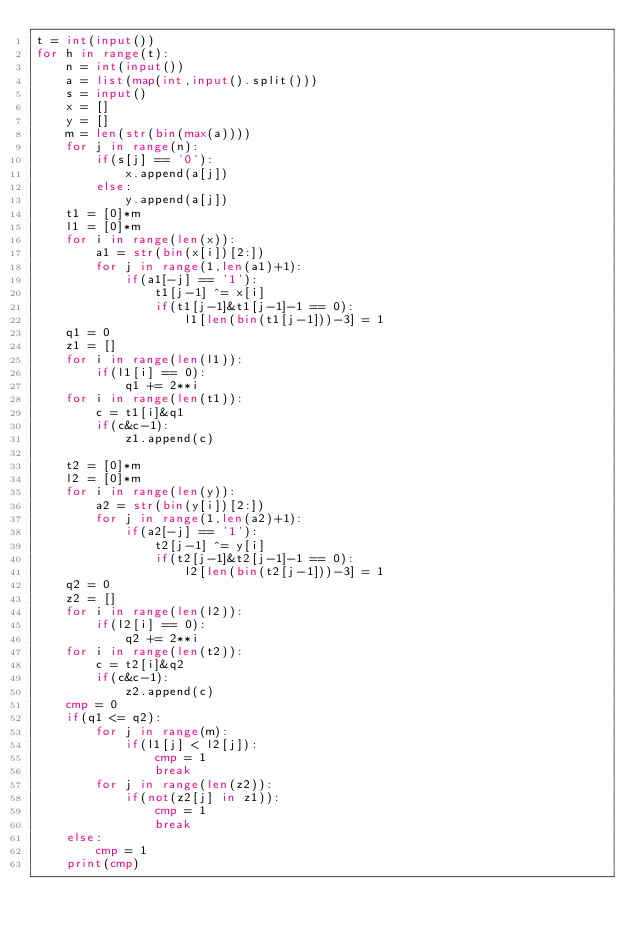<code> <loc_0><loc_0><loc_500><loc_500><_Python_>t = int(input())
for h in range(t):
    n = int(input())
    a = list(map(int,input().split()))
    s = input()
    x = []
    y = []
    m = len(str(bin(max(a))))
    for j in range(n):
        if(s[j] == '0'):
            x.append(a[j])
        else:
            y.append(a[j])
    t1 = [0]*m
    l1 = [0]*m
    for i in range(len(x)):
        a1 = str(bin(x[i])[2:])
        for j in range(1,len(a1)+1):
            if(a1[-j] == '1'):
                t1[j-1] ^= x[i]
                if(t1[j-1]&t1[j-1]-1 == 0):
                    l1[len(bin(t1[j-1]))-3] = 1
    q1 = 0
    z1 = []
    for i in range(len(l1)):
        if(l1[i] == 0):
            q1 += 2**i
    for i in range(len(t1)):
        c = t1[i]&q1
        if(c&c-1):
            z1.append(c)
            
    t2 = [0]*m
    l2 = [0]*m
    for i in range(len(y)):
        a2 = str(bin(y[i])[2:])
        for j in range(1,len(a2)+1):
            if(a2[-j] == '1'):
                t2[j-1] ^= y[i]
                if(t2[j-1]&t2[j-1]-1 == 0):
                    l2[len(bin(t2[j-1]))-3] = 1
    q2 = 0
    z2 = []
    for i in range(len(l2)):
        if(l2[i] == 0):
            q2 += 2**i
    for i in range(len(t2)):
        c = t2[i]&q2
        if(c&c-1):
            z2.append(c)
    cmp = 0
    if(q1 <= q2):
        for j in range(m):
            if(l1[j] < l2[j]):
                cmp = 1
                break
        for j in range(len(z2)):
            if(not(z2[j] in z1)):
                cmp = 1
                break
    else:
        cmp = 1
    print(cmp)</code> 